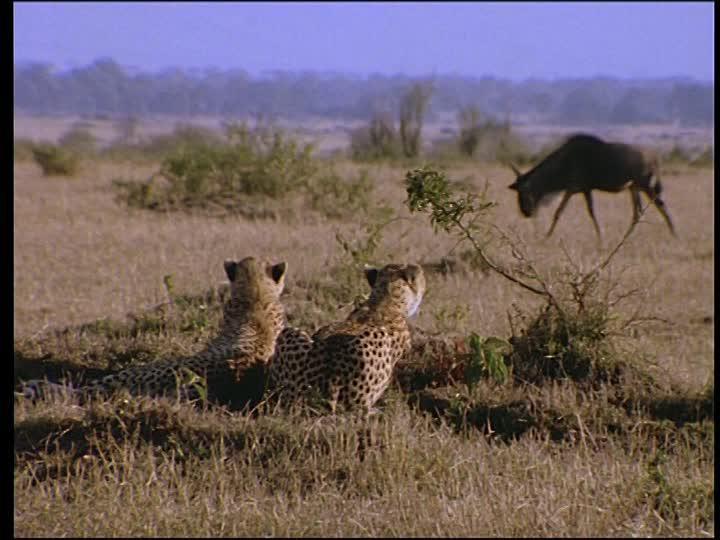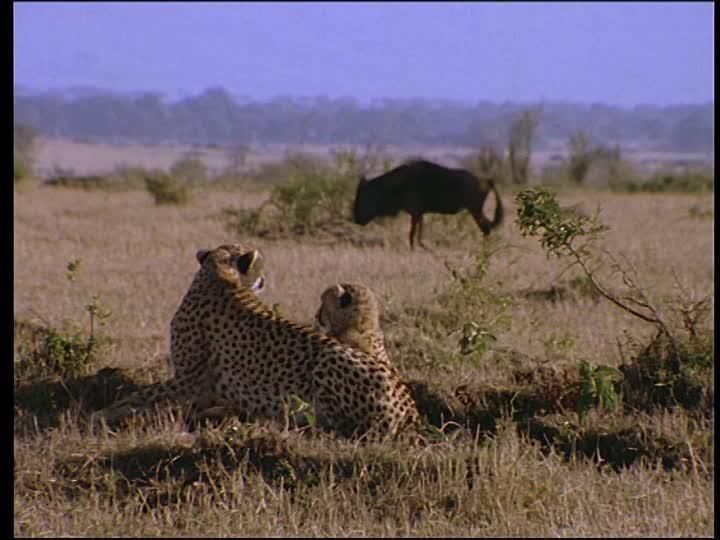The first image is the image on the left, the second image is the image on the right. Considering the images on both sides, is "Atleast one image contains 2 cheetahs fighting another animal" valid? Answer yes or no. No. 